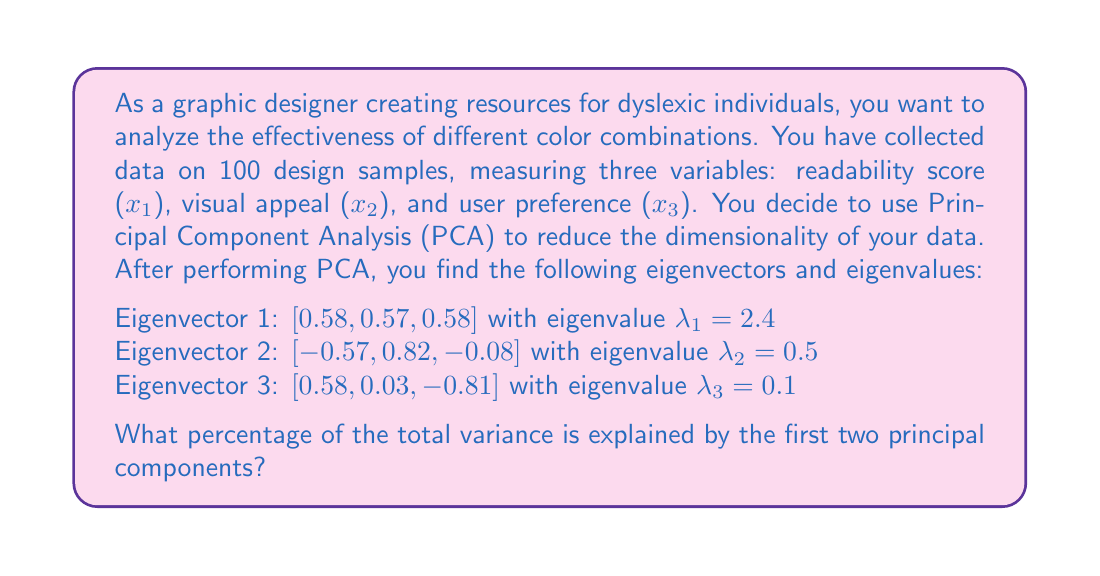Can you answer this question? To solve this problem, we need to follow these steps:

1. Calculate the total variance
2. Calculate the variance explained by the first two principal components
3. Calculate the percentage of variance explained by the first two principal components

Step 1: Calculate the total variance
The total variance is the sum of all eigenvalues:

$$ \text{Total Variance} = \lambda_1 + \lambda_2 + \lambda_3 = 2.4 + 0.5 + 0.1 = 3 $$

Step 2: Calculate the variance explained by the first two principal components
The variance explained by each principal component is equal to its corresponding eigenvalue. So, the variance explained by the first two principal components is:

$$ \text{Variance Explained} = \lambda_1 + \lambda_2 = 2.4 + 0.5 = 2.9 $$

Step 3: Calculate the percentage of variance explained by the first two principal components
To calculate the percentage, we divide the variance explained by the first two principal components by the total variance and multiply by 100:

$$ \text{Percentage of Variance Explained} = \frac{\text{Variance Explained}}{\text{Total Variance}} \times 100\% $$

$$ = \frac{2.9}{3} \times 100\% = 0.9666... \times 100\% \approx 96.67\% $$

Therefore, the first two principal components explain approximately 96.67% of the total variance in the data.
Answer: 96.67% 